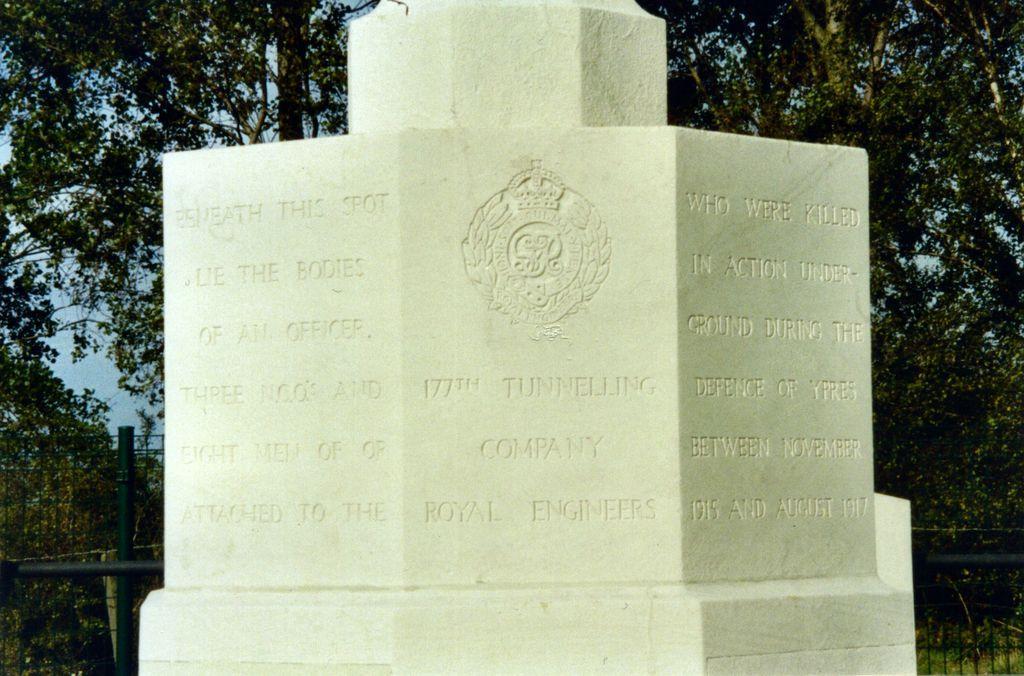Please provide a concise description of this image. In this image, we can see a memorial stone. There is a fencing in the bottom left and in the bottom right of the image. In the background of the image, there are some trees. 